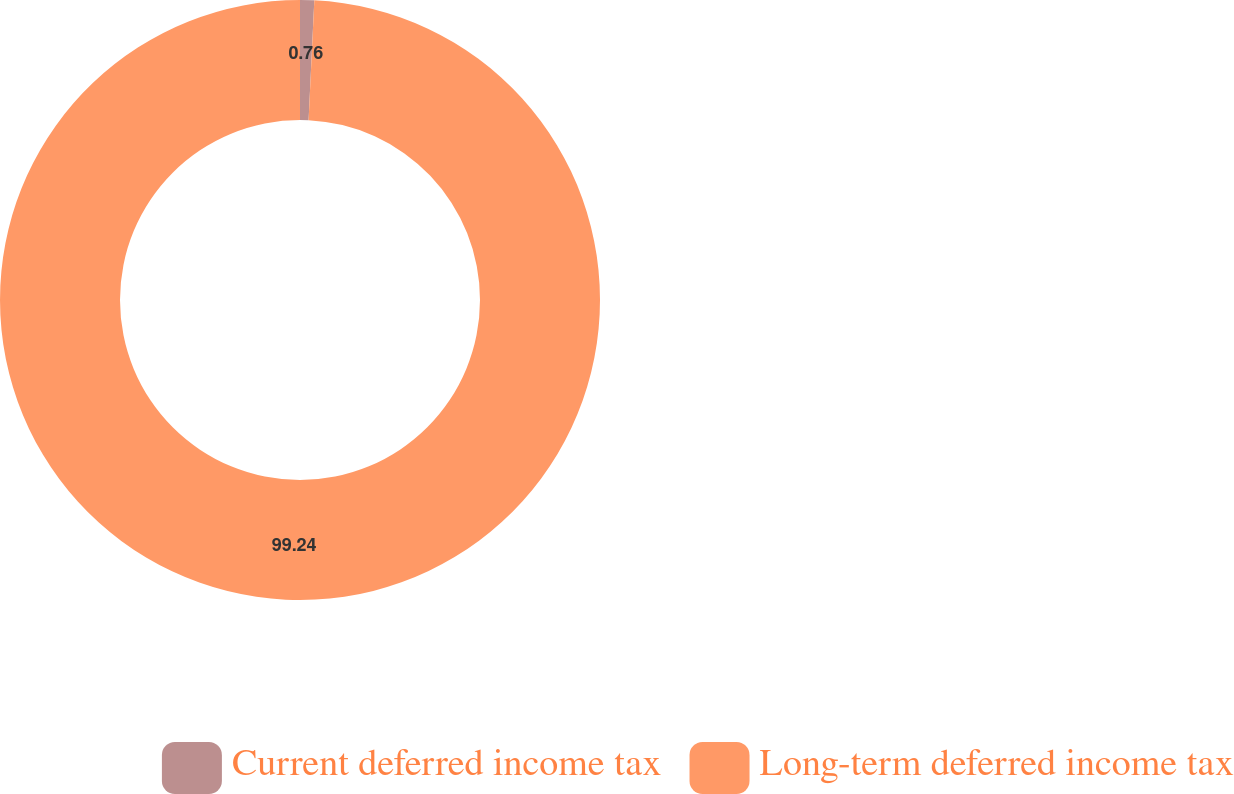Convert chart to OTSL. <chart><loc_0><loc_0><loc_500><loc_500><pie_chart><fcel>Current deferred income tax<fcel>Long-term deferred income tax<nl><fcel>0.76%<fcel>99.24%<nl></chart> 